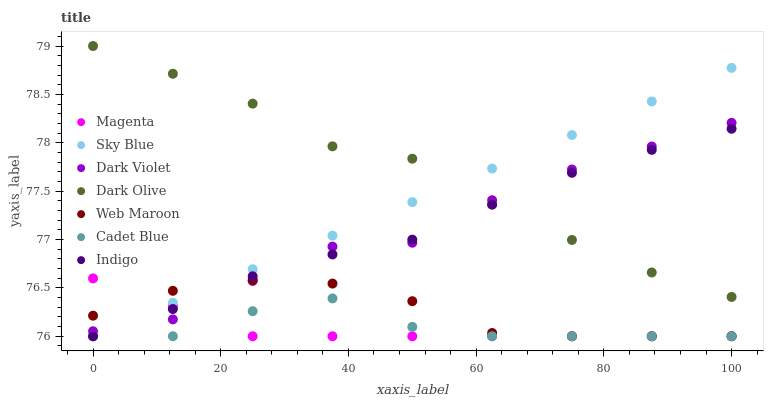Does Magenta have the minimum area under the curve?
Answer yes or no. Yes. Does Dark Olive have the maximum area under the curve?
Answer yes or no. Yes. Does Indigo have the minimum area under the curve?
Answer yes or no. No. Does Indigo have the maximum area under the curve?
Answer yes or no. No. Is Sky Blue the smoothest?
Answer yes or no. Yes. Is Dark Violet the roughest?
Answer yes or no. Yes. Is Indigo the smoothest?
Answer yes or no. No. Is Indigo the roughest?
Answer yes or no. No. Does Cadet Blue have the lowest value?
Answer yes or no. Yes. Does Dark Olive have the lowest value?
Answer yes or no. No. Does Dark Olive have the highest value?
Answer yes or no. Yes. Does Indigo have the highest value?
Answer yes or no. No. Is Magenta less than Dark Olive?
Answer yes or no. Yes. Is Dark Olive greater than Magenta?
Answer yes or no. Yes. Does Sky Blue intersect Magenta?
Answer yes or no. Yes. Is Sky Blue less than Magenta?
Answer yes or no. No. Is Sky Blue greater than Magenta?
Answer yes or no. No. Does Magenta intersect Dark Olive?
Answer yes or no. No. 